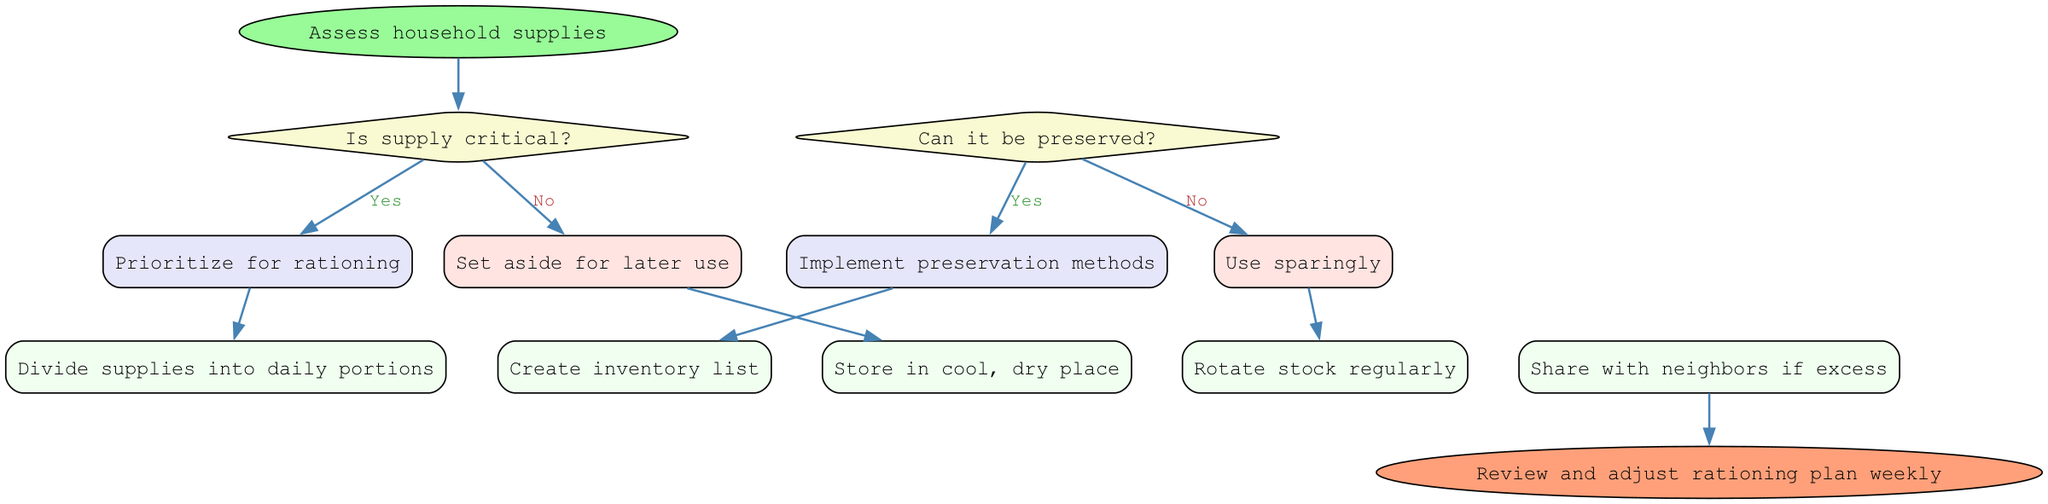What is the starting point of the procedure? The starting point of the procedure, as indicated in the diagram, is "Assess household supplies." This is the first action taken before any decisions are made.
Answer: Assess household supplies How many decision nodes are in the diagram? The diagram contains two decision nodes, each representing a critical condition regarding the household supplies. This can be derived from counting the diamond-shaped nodes in the diagram.
Answer: 2 What happens if the supply is not critical? If the supply is not critical, the action taken is "Set aside for later use." This is the direct outcome from the relevant decision node for this condition.
Answer: Set aside for later use What action follows the decision to prioritize for rationing? After the decision to prioritize for rationing, the next action is "Divide supplies into daily portions." This connects the decision node directly to this action node.
Answer: Divide supplies into daily portions What is the final outcome of the diagram? The final outcome of the diagram is "Review and adjust rationing plan weekly." This is represented by the end node and indicates the completion of the process.
Answer: Review and adjust rationing plan weekly What is done if supplies can be preserved? If supplies can be preserved, the action taken is "Implement preservation methods." This is the response linked to the decision node regarding preservation capabilities.
Answer: Implement preservation methods Which action is related to managing stock? The action related to managing stock is "Rotate stock regularly." This is mentioned as one of the actions in managing the supplies effectively within the procedure.
Answer: Rotate stock regularly What happens if supplies cannot be preserved? If supplies cannot be preserved, the action is "Use sparingly." This follows from the relevant decision node regarding preservation methods.
Answer: Use sparingly 